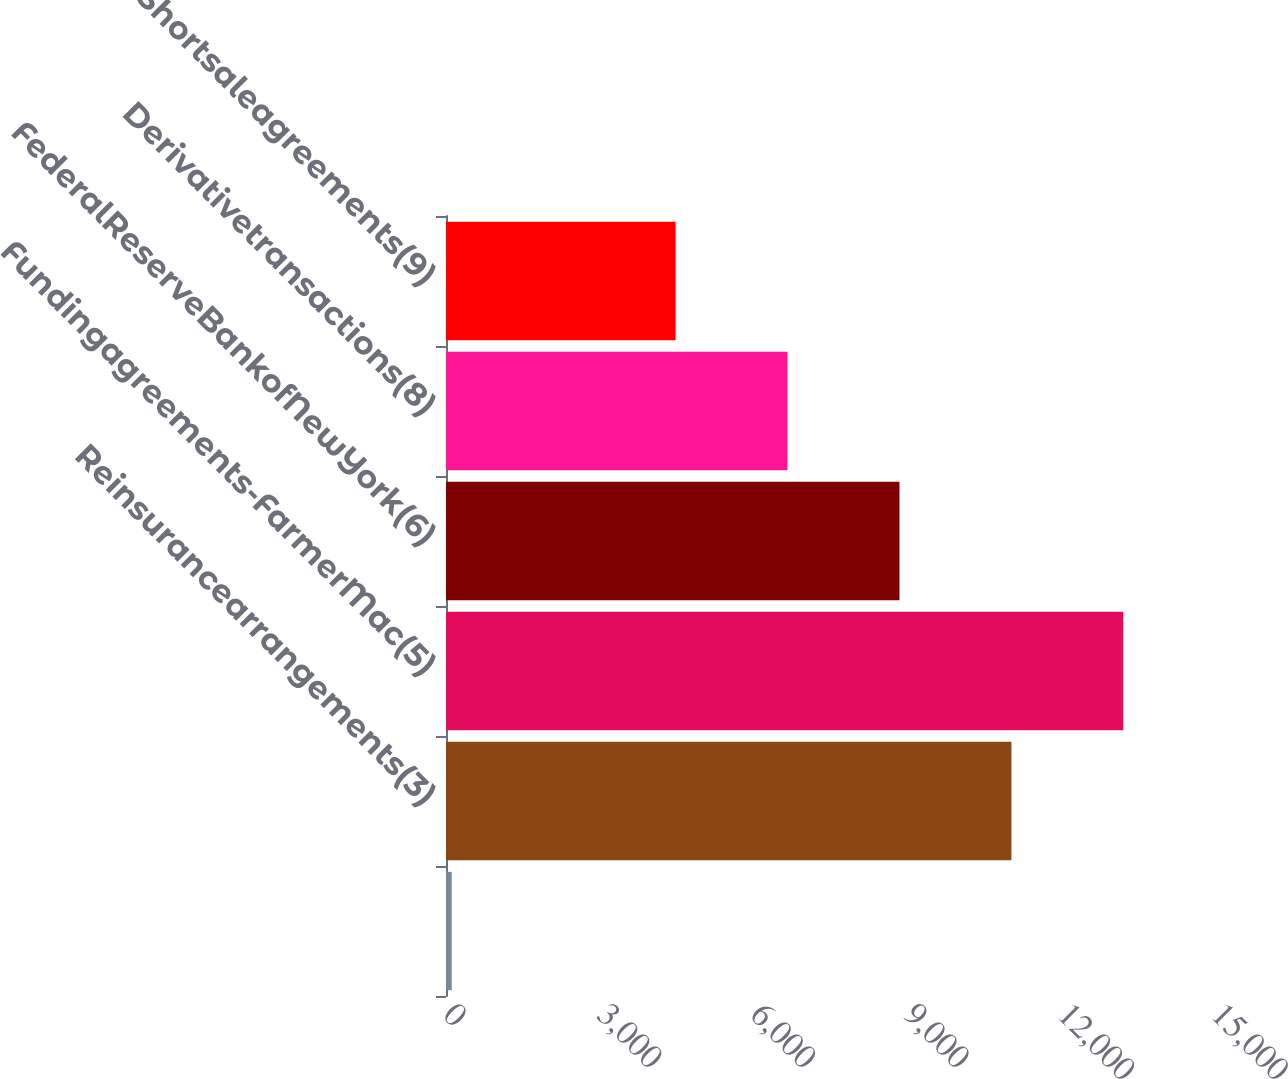<chart> <loc_0><loc_0><loc_500><loc_500><bar_chart><ecel><fcel>Reinsurancearrangements(3)<fcel>Fundingagreements-FarmerMac(5)<fcel>FederalReserveBankofNewYork(6)<fcel>Derivativetransactions(8)<fcel>Shortsaleagreements(9)<nl><fcel>112<fcel>11043.5<fcel>13229.8<fcel>8857.2<fcel>6670.9<fcel>4484.6<nl></chart> 